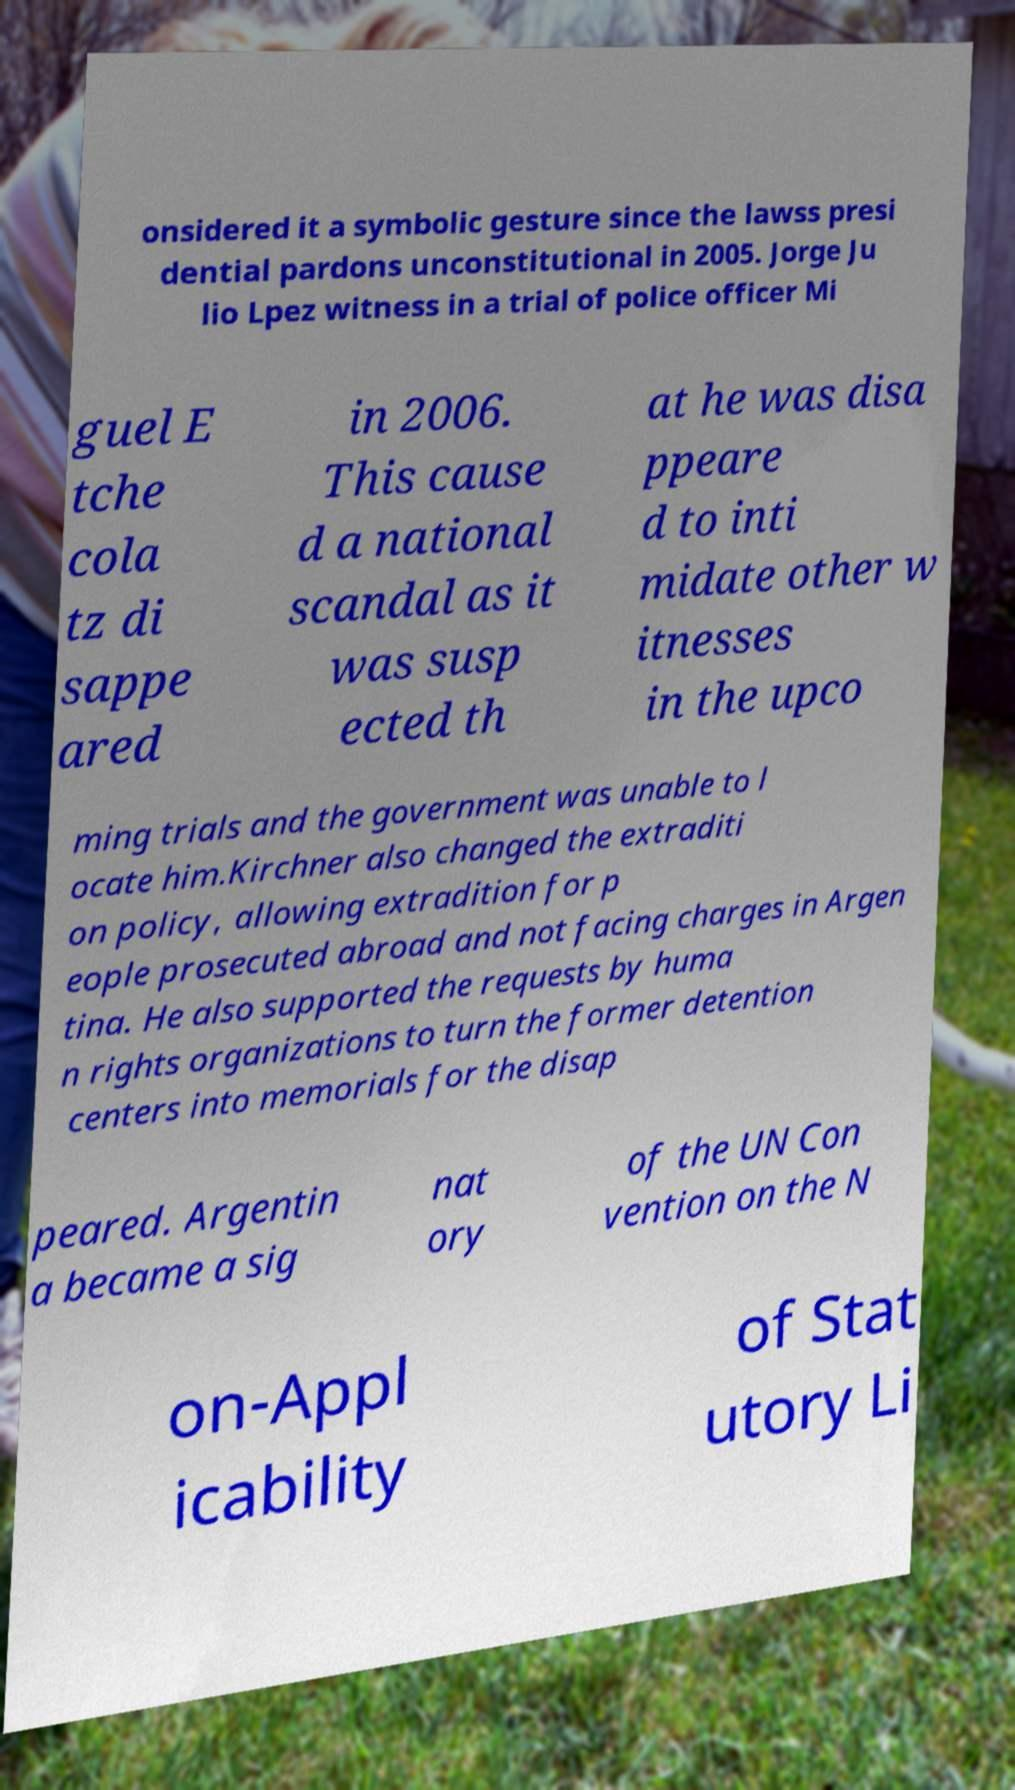Can you read and provide the text displayed in the image?This photo seems to have some interesting text. Can you extract and type it out for me? onsidered it a symbolic gesture since the lawss presi dential pardons unconstitutional in 2005. Jorge Ju lio Lpez witness in a trial of police officer Mi guel E tche cola tz di sappe ared in 2006. This cause d a national scandal as it was susp ected th at he was disa ppeare d to inti midate other w itnesses in the upco ming trials and the government was unable to l ocate him.Kirchner also changed the extraditi on policy, allowing extradition for p eople prosecuted abroad and not facing charges in Argen tina. He also supported the requests by huma n rights organizations to turn the former detention centers into memorials for the disap peared. Argentin a became a sig nat ory of the UN Con vention on the N on-Appl icability of Stat utory Li 